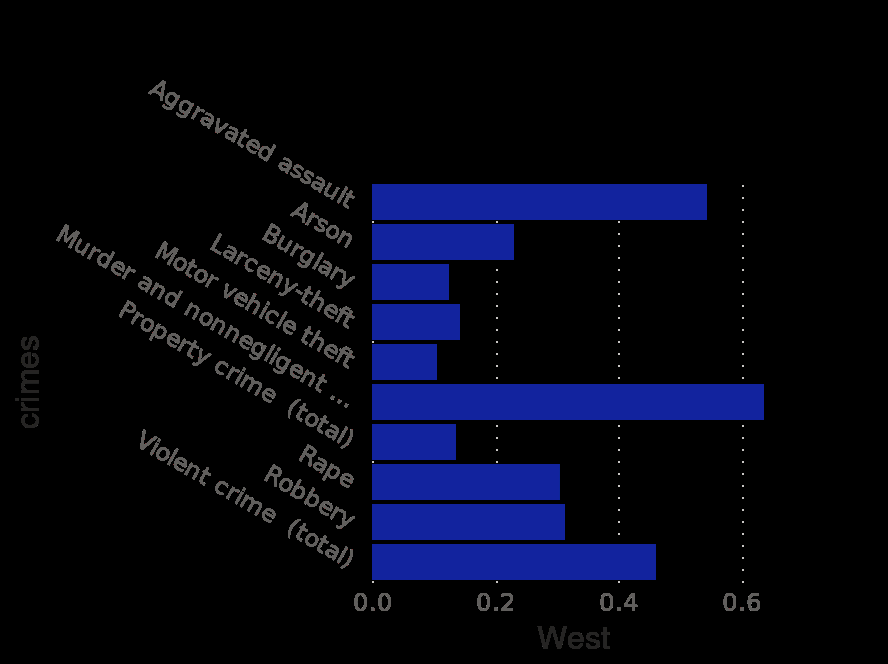<image>
Were the clearance rates for murders and violent assault similar? Yes, both murders and violent assault had higher clearance rates. Why did some crimes have lower clearance rates? Some crimes may be harder to solve, leading to lower clearance rates. What time period does the bar chart represent?  The bar chart represents the crime clearance rate specifically in the year 2019 in the United States. Does the bar chart represent the crime clearance rate specifically in the year 2020 in the United States? No. The bar chart represents the crime clearance rate specifically in the year 2019 in the United States. 